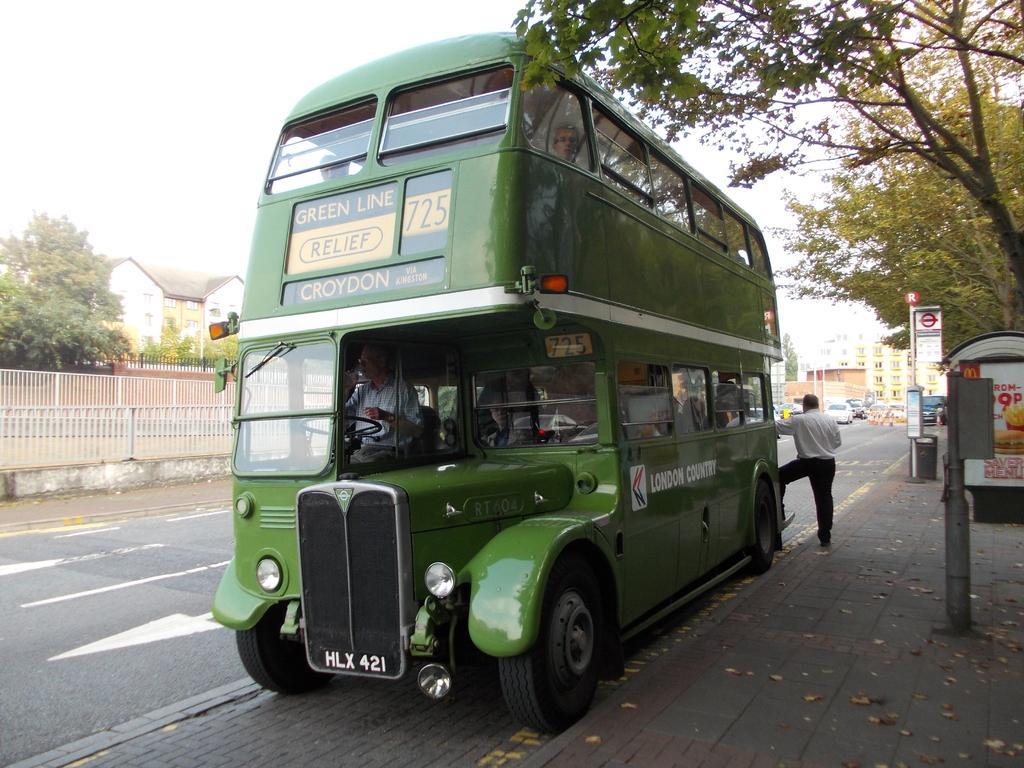Describe this image in one or two sentences. In this picture there is a driver who is driving a green double bus. Beside that we can see another man who is standing near to the bus stairs. On the right we can see the sign boards, poles, street lights and other objects. On the left we can see the buildings, trees and fencing. in the background we can see many cars on the road. At the top there is a sky. 